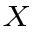Convert formula to latex. <formula><loc_0><loc_0><loc_500><loc_500>_ { X }</formula> 